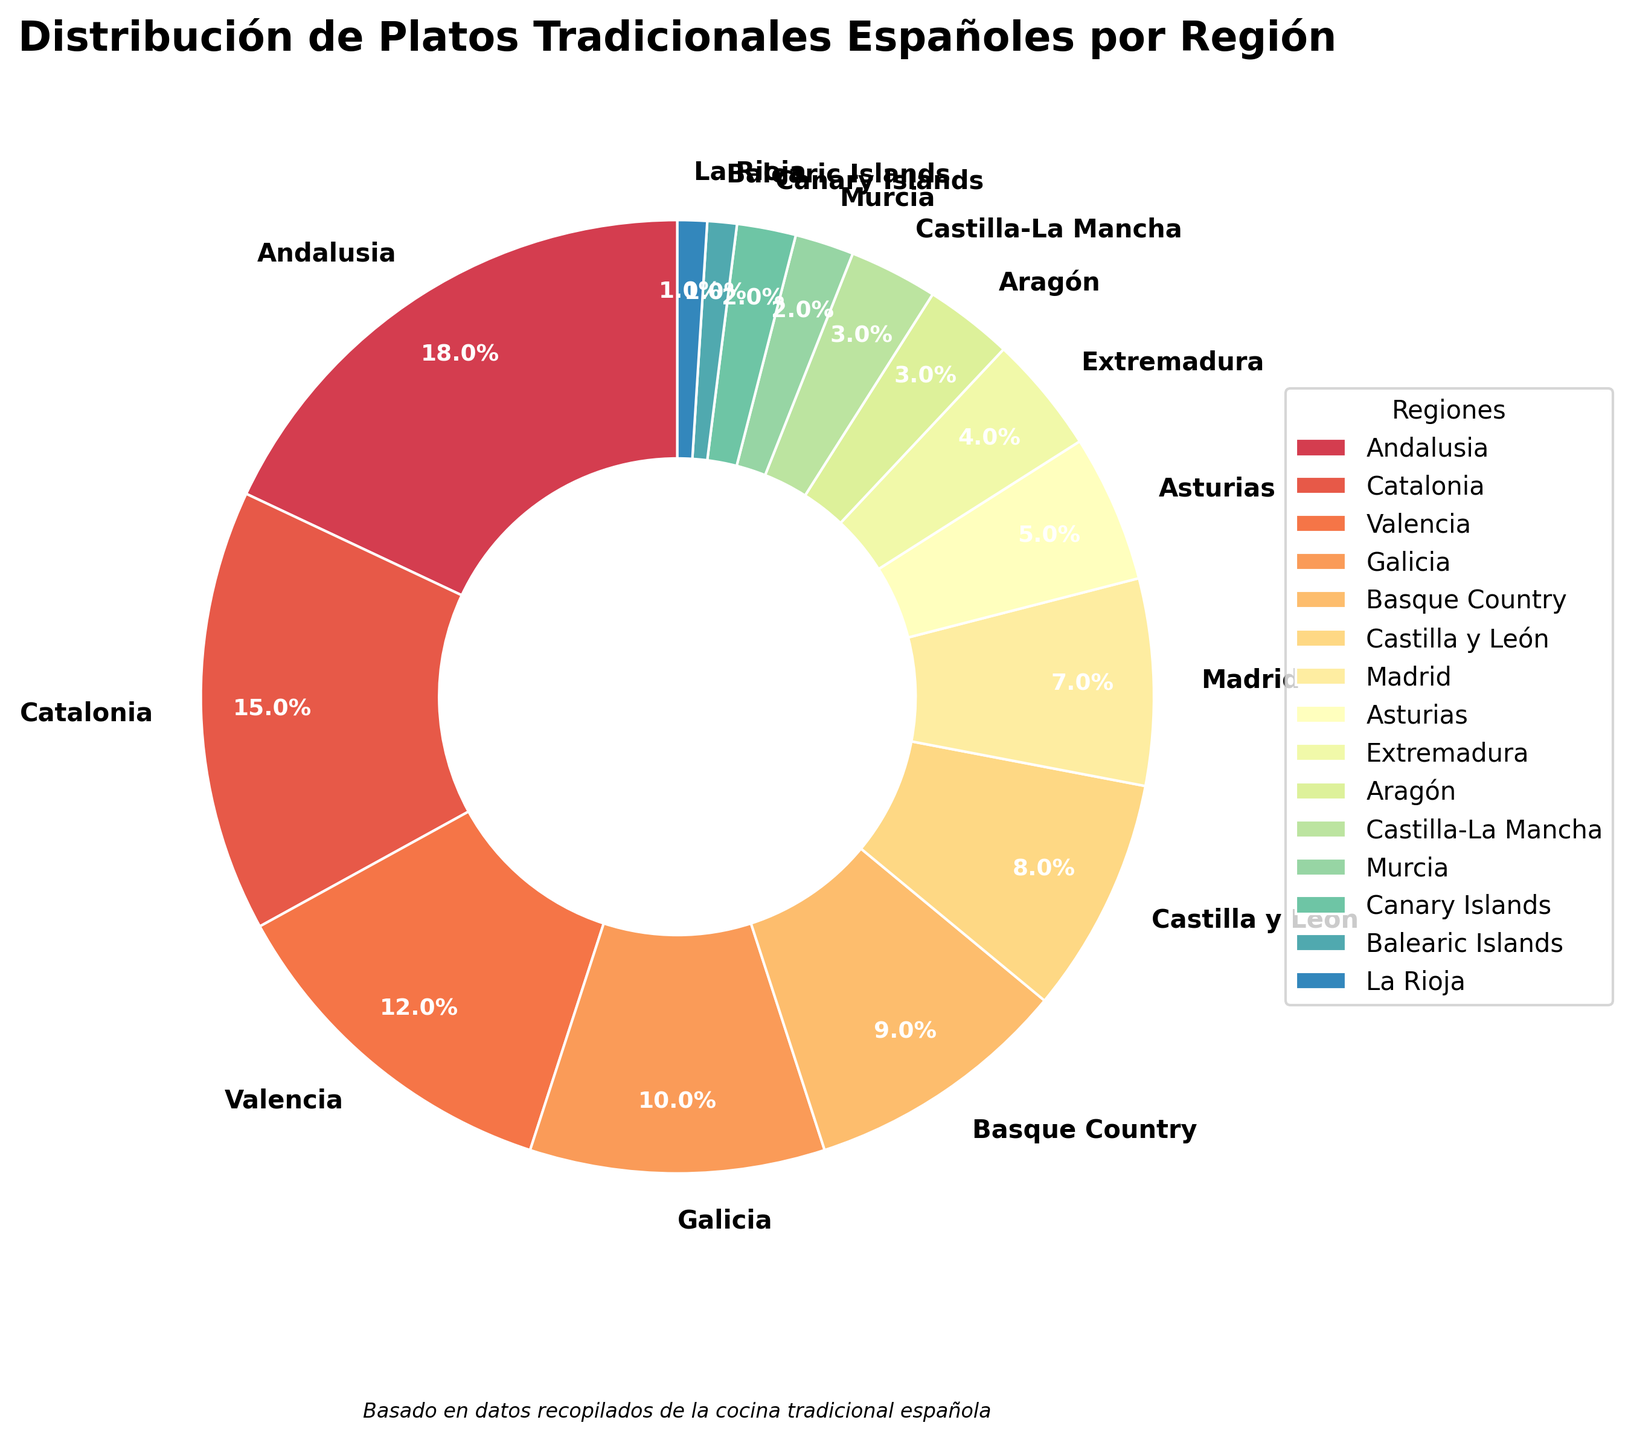Which region has the highest percentage of traditional Spanish dishes? The region with the highest percentage of traditional Spanish dishes is identified by the largest slice in the pie chart. Andalusia has the largest slice with 18%.
Answer: Andalusia What is the combined percentage of traditional dishes from Andalusia and Catalonia? Add the percentages of Andalusia and Catalonia: 18% (Andalusia) + 15% (Catalonia) = 33%.
Answer: 33% Which region has the smallest percentage of traditional Spanish dishes? The region with the smallest percentage of traditional Spanish dishes is identified by the smallest slice in the pie chart. Both La Rioja and Balearic Islands have the smallest slices, each with 1%.
Answer: La Rioja and Balearic Islands Is the percentage of Basque Country higher than that of Madrid? Compare the percentages: Basque Country has 9%, and Madrid has 7%. Since 9% > 7%, Basque Country's percentage is higher.
Answer: Yes What’s the total percentage of traditional dishes from regions with less than 5% each? Identify the regions with less than 5%: Extremadura (4%), Aragón (3%), Castilla-La Mancha (3%), Murcia (2%), Canary Islands (2%), Balearic Islands (1%), and La Rioja (1%). Sum their percentages: 4% + 3% + 3% + 2% + 2% + 1% + 1% = 16%.
Answer: 16% Compare the percentage of traditional dishes between Valencia and Galicia. Which one is higher and by how much? Valencia has 12%, and Galicia has 10%. Subtract the smaller percentage from the larger percentage: 12% - 10% = 2%. Valencia's percentage is higher by 2%.
Answer: Valencia by 2% Which region ranks third in terms of the percentage of traditional Spanish dishes? The third largest slice in the pie chart corresponds to Valencia, which has 12%, after Andalusia (18%) and Catalonia (15%).
Answer: Valencia Is the sum of the percentages from Asturias and Extremadura greater than that of Castilla y León? Asturias has 5%, and Extremadura has 4%. Their combined percentage is 5% + 4% = 9%. Castilla y León has 8%. Since 9% > 8%, the sum is greater.
Answer: Yes What is the average percentage of traditional dishes from the regions of Asturias, Extremadura, and Aragón? Add the percentages: 5% (Asturias) + 4% (Extremadura) + 3% (Aragón) = 12%. Divide by the number of regions, which is 3. 12% / 3 = 4%.
Answer: 4% If we combine the dishes from Canary Islands, Balearic Islands, and La Rioja, what percentage of traditional dishes do these island regions contribute? Add the percentages of Canary Islands (2%), Balearic Islands (1%), and La Rioja (1%): 2% + 1% + 1% = 4%.
Answer: 4% 